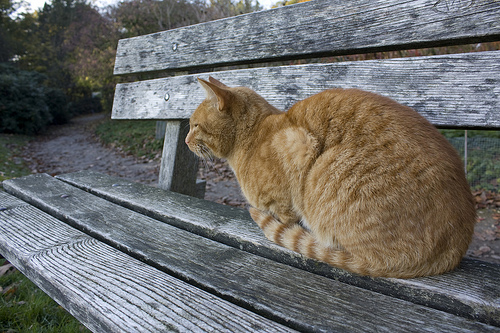What is the bench in front of? The bench is in front of a path. 